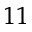Convert formula to latex. <formula><loc_0><loc_0><loc_500><loc_500>^ { 1 1 }</formula> 